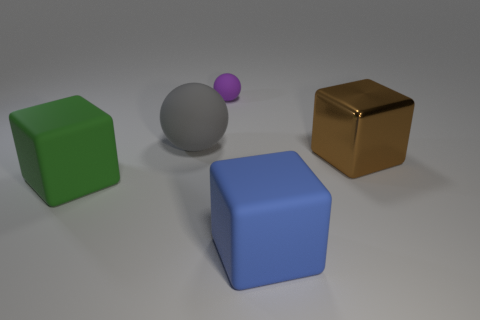What number of other objects are the same size as the purple sphere? 0 